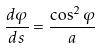<formula> <loc_0><loc_0><loc_500><loc_500>\frac { d \varphi } { d s } = \frac { \cos ^ { 2 } \varphi } { a }</formula> 